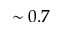<formula> <loc_0><loc_0><loc_500><loc_500>\sim 0 . 7</formula> 